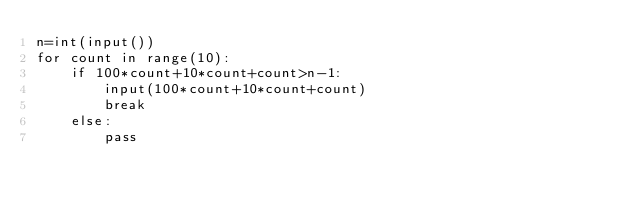Convert code to text. <code><loc_0><loc_0><loc_500><loc_500><_Python_>n=int(input())
for count in range(10):
    if 100*count+10*count+count>n-1:
        input(100*count+10*count+count)
        break
    else:
        pass</code> 